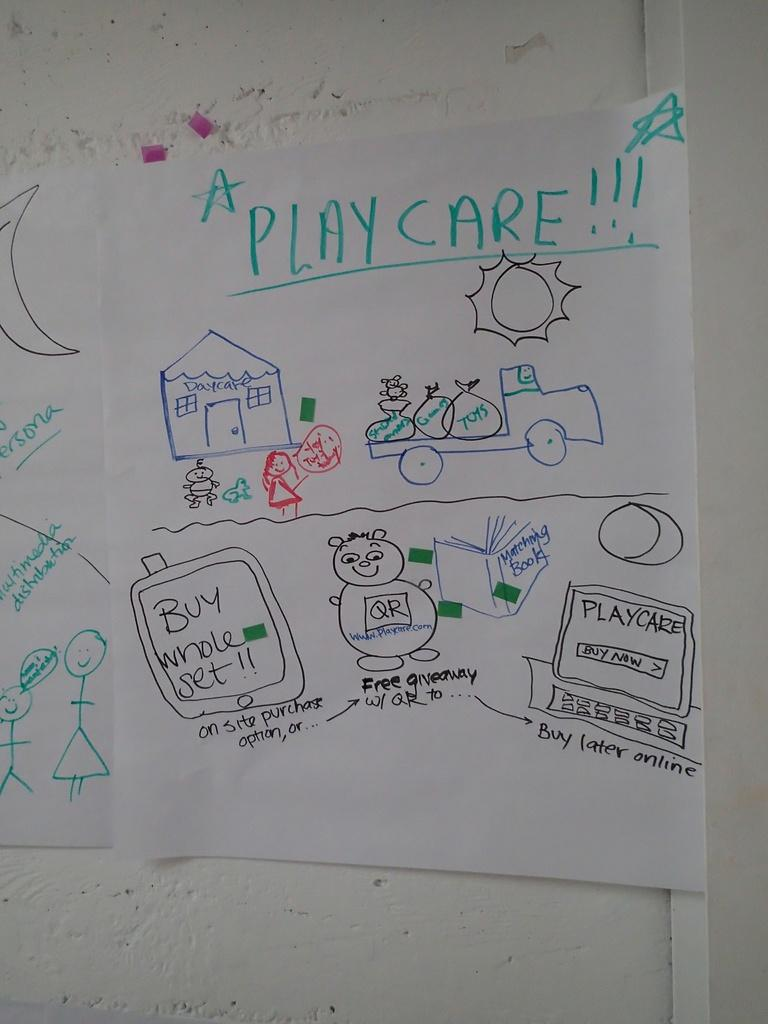<image>
Share a concise interpretation of the image provided. A piece of paper says "PLAY CARE!!!" and has drawings of a house and truck on it. 